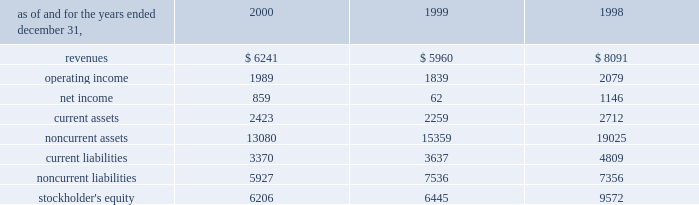A e s 2 0 0 0 f i n a n c i a l r e v i e w in may 2000 , a subsidiary of the company acquired an additional 5% ( 5 % ) of the preferred , non-voting shares of eletropaulo for approximately $ 90 million .
In january 2000 , 59% ( 59 % ) of the preferred non-voting shares were acquired for approximately $ 1 billion at auction from bndes , the national development bank of brazil .
The price established at auction was approximately $ 72.18 per 1000 shares , to be paid in four annual installments com- mencing with a payment of 18.5% ( 18.5 % ) of the total price upon closing of the transaction and installments of 25.9% ( 25.9 % ) , 27.1% ( 27.1 % ) and 28.5% ( 28.5 % ) of the total price to be paid annually thereafter .
At december 31 , 2000 , the company had a total economic interest of 49.6% ( 49.6 % ) in eletropaulo .
The company accounts for this investment using the equity method based on the related consortium agreement that allows the exercise of significant influence .
In august 2000 , a subsidiary of the company acquired a 49% ( 49 % ) interest in songas limited for approxi- mately $ 40 million .
Songas limited owns the songo songo gas-to-electricity project in tanzania .
Under the terms of a project management agreement , the company has assumed overall project management responsibility .
The project consists of the refurbishment and operation of five natural gas wells in coastal tanzania , the construction and operation of a 65 mmscf/day gas processing plant and related facilities , the construction of a 230 km marine and land pipeline from the gas plant to dar es salaam and the conversion and upgrading of an existing 112 mw power station in dar es salaam to burn natural gas , with an optional additional unit to be constructed at the plant .
Since the project is currently under construction , no rev- enues or expenses have been incurred , and therefore no results are shown in the table .
In december 2000 , a subsidiary of the company with edf international s.a .
( 201cedf 201d ) completed the acquisition of an additional 3.5% ( 3.5 % ) interest in light from two sub- sidiaries of reliant energy for approximately $ 136 mil- lion .
Pursuant to the acquisition , the company acquired 30% ( 30 % ) of the shares while edf acquired the remainder .
With the completion of this transaction , the company owns approximately 21.14% ( 21.14 % ) of light .
In december 2000 , a subsidiary of the company entered into an agreement with edf to jointly acquire an additional 9.2% ( 9.2 % ) interest in light , which is held by a sub- sidiary of companhia siderurgica nacional ( 201ccsn 201d ) .
Pursuant to this transaction , the company acquired an additional 2.75% ( 2.75 % ) interest in light for $ 114.6 million .
This transaction closed in january 2001 .
Following the purchase of the light shares previously owned by csn , aes and edf will together be the con- trolling shareholders of light and eletropaulo .
Aes and edf have agreed that aes will eventually take operational control of eletropaulo and the telecom businesses of light and eletropaulo , while edf will eventually take opera- tional control of light and eletropaulo 2019s electric workshop business .
Aes and edf intend to continue to pursue a fur- ther rationalization of their ownership stakes in light and eletropaulo , the result of which aes would become the sole controlling shareholder of eletropaulo and edf would become the sole controlling shareholder of light .
Upon consummation of the transaction , aes will begin consolidating eletropaulo 2019s operating results .
The struc- ture and process by which this rationalization may be effected , and the resulting timing , have yet to be deter- mined and will likely be subject to approval by various brazilian regulatory authorities and other third parties .
As a result , there can be no assurance that this rationalization will take place .
In may 1999 , a subsidiary of the company acquired subscription rights from the brazilian state-controlled eletrobras which allowed it to purchase preferred , non- voting shares in eletropaulo and common shares in light .
The aggregate purchase price of the subscription rights and the underlying shares in light and eletropaulo was approximately $ 53 million and $ 77 million , respectively , and represented 3.7% ( 3.7 % ) and 4.4% ( 4.4 % ) economic ownership interest in their capital stock , respectively .
The table presents summarized financial information ( in millions ) for the company 2019s investments in 50% ( 50 % ) or less owned investments accounted for using the equity method: .

What was the change in revenue for the company 2019s investments in 50% ( 50 % ) or less owned investments accounted for using the equity method between 1999 and 2000? 
Computations: ((6241 - 5960) / 5960)
Answer: 0.04715. 